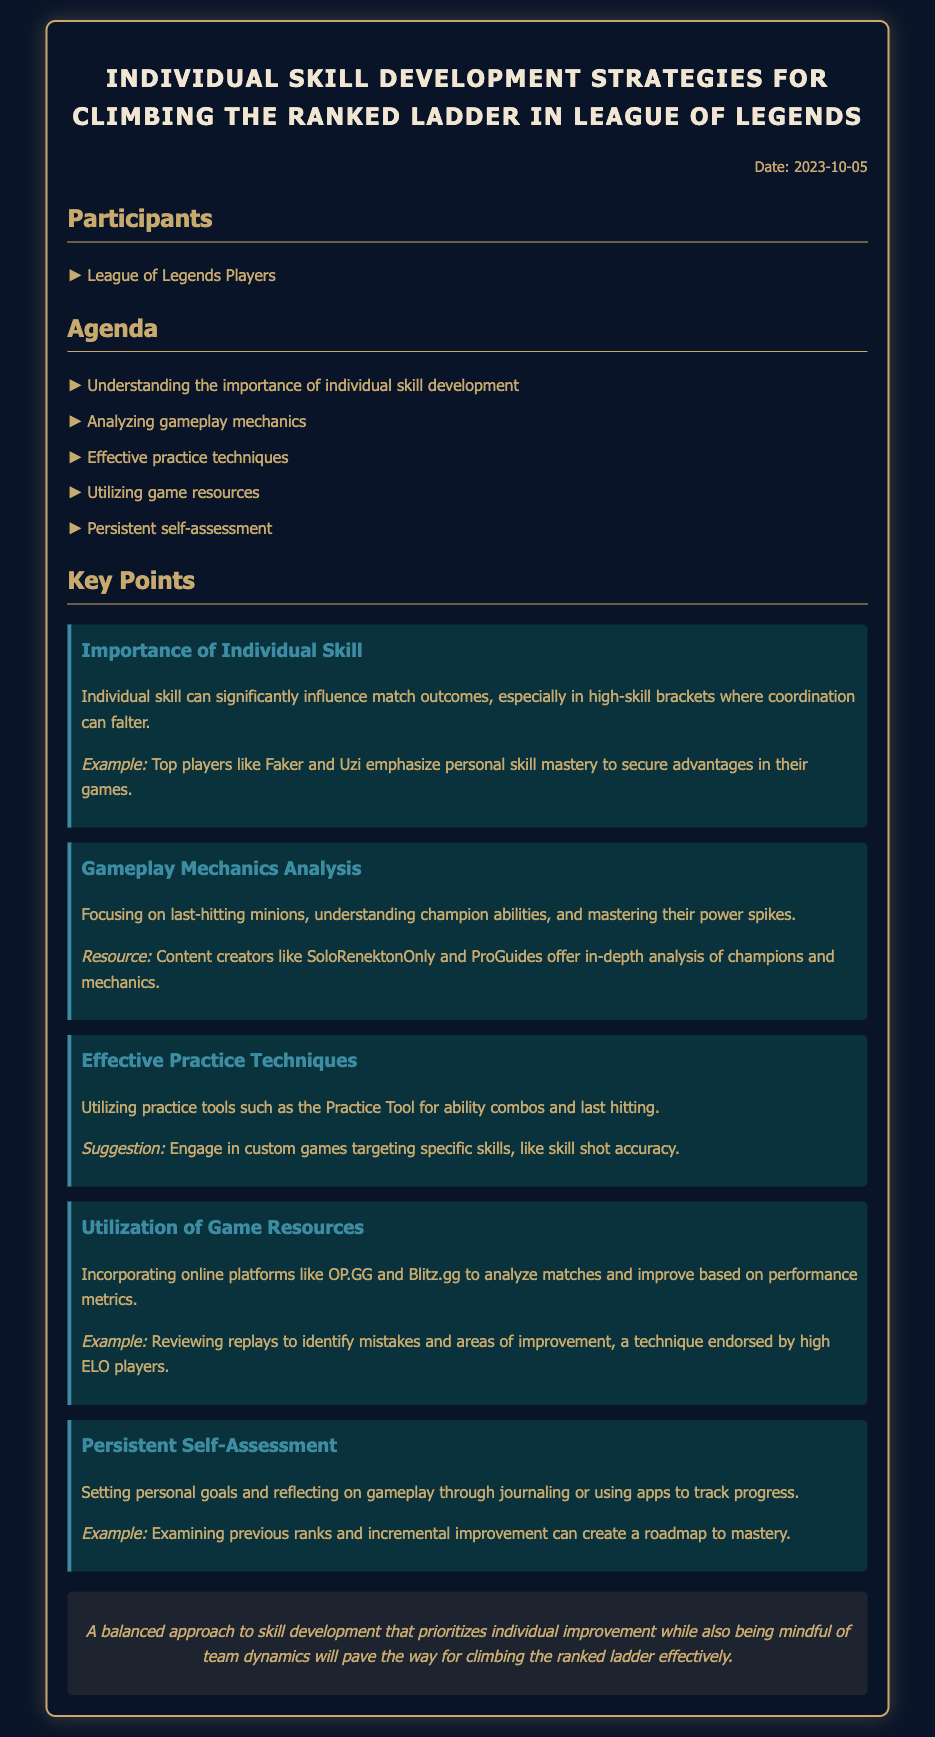What is the date of the meeting? The date of the meeting is mentioned in the document, which is 2023-10-05.
Answer: 2023-10-05 Who are the participants in the meeting? The document lists the participants, which are simply League of Legends Players.
Answer: League of Legends Players What is emphasized as important in the key points? The key point section highlights the importance of individual skill development in gameplay.
Answer: Individual skill Which practice tool is suggested for improving skills? The document suggests using the Practice Tool for practicing ability combos and last hitting.
Answer: Practice Tool What is a recommended online platform for match analysis? The document mentions OP.GG and Blitz.gg as platforms to analyze matches.
Answer: OP.GG and Blitz.gg What is one effective practice technique mentioned? Engaging in custom games targeting specific skills is one of the effective practice techniques mentioned.
Answer: Custom games What does the conclusion emphasize for climbing the ranked ladder? The conclusion emphasizes a balanced approach, prioritizing individual improvement while considering team dynamics.
Answer: Balanced approach Which content creators are mentioned for gameplay mechanics analysis? The document references SoloRenektonOnly and ProGuides for in-depth analyses of champions and gameplay mechanics.
Answer: SoloRenektonOnly and ProGuides 